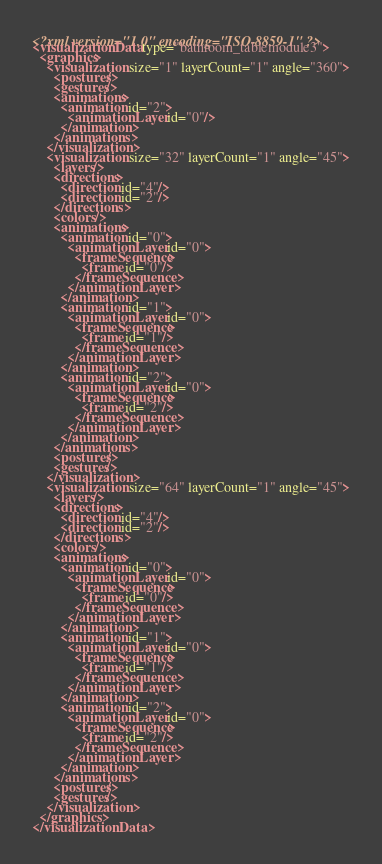Convert code to text. <code><loc_0><loc_0><loc_500><loc_500><_XML_><?xml version="1.0" encoding="ISO-8859-1" ?><visualizationData type="bathroom_tablemodule3">
  <graphics>
    <visualization size="1" layerCount="1" angle="360">
      <postures/>
      <gestures/>
      <animations>
        <animation id="2">
          <animationLayer id="0"/>
        </animation>
      </animations>
    </visualization>
    <visualization size="32" layerCount="1" angle="45">
      <layers/>
      <directions>
        <direction id="4"/>
        <direction id="2"/>
      </directions>
      <colors/>
      <animations>
        <animation id="0">
          <animationLayer id="0">
            <frameSequence>
              <frame id="0"/>
            </frameSequence>
          </animationLayer>
        </animation>
        <animation id="1">
          <animationLayer id="0">
            <frameSequence>
              <frame id="1"/>
            </frameSequence>
          </animationLayer>
        </animation>
        <animation id="2">
          <animationLayer id="0">
            <frameSequence>
              <frame id="2"/>
            </frameSequence>
          </animationLayer>
        </animation>
      </animations>
      <postures/>
      <gestures/>
    </visualization>
    <visualization size="64" layerCount="1" angle="45">
      <layers/>
      <directions>
        <direction id="4"/>
        <direction id="2"/>
      </directions>
      <colors/>
      <animations>
        <animation id="0">
          <animationLayer id="0">
            <frameSequence>
              <frame id="0"/>
            </frameSequence>
          </animationLayer>
        </animation>
        <animation id="1">
          <animationLayer id="0">
            <frameSequence>
              <frame id="1"/>
            </frameSequence>
          </animationLayer>
        </animation>
        <animation id="2">
          <animationLayer id="0">
            <frameSequence>
              <frame id="2"/>
            </frameSequence>
          </animationLayer>
        </animation>
      </animations>
      <postures/>
      <gestures/>
    </visualization>
  </graphics>
</visualizationData></code> 